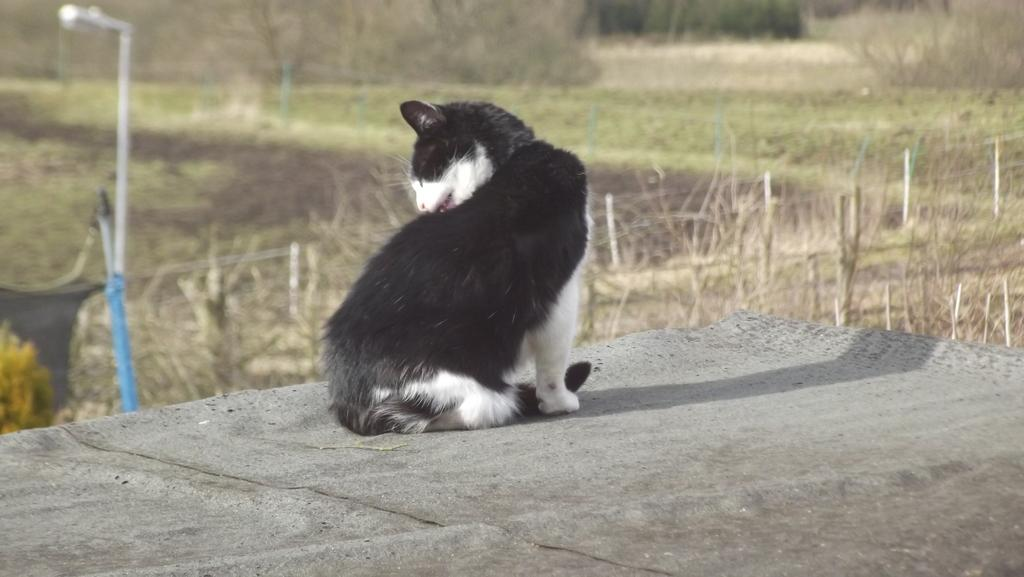What animal is located in the middle of the image? There is a cat in the middle of the image. What structure can be seen on the left side of the image? There is a street lamp on the left side of the image. What type of vegetation is visible in the background of the image? There are trees in the background of the image. Where is the store located in the image? There is no store present in the image. What type of powder is being used by the cat in the image? There is no powder visible in the image, and the cat is not performing any action that would involve powder. 